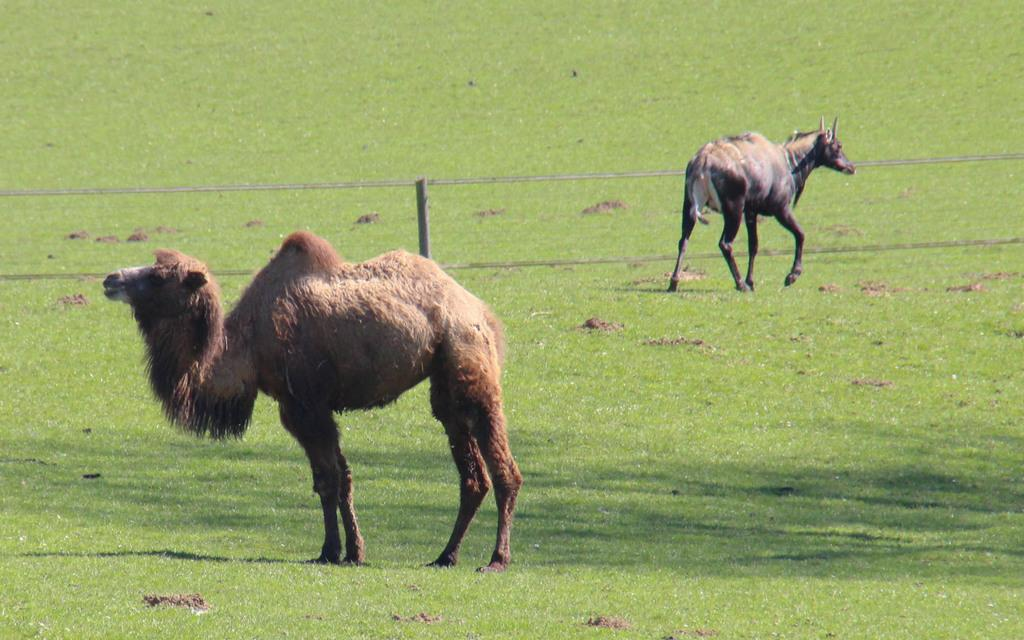How many animals are present in the image? There are two animals in the image. What is the surface on which the animals are standing? The animals are standing on the grass. What can be seen in the background of the image? There is a fence in the image. What type of knife is being used by one of the animals in the image? There is no knife present in the image, and neither of the animals is using any tool or object. 